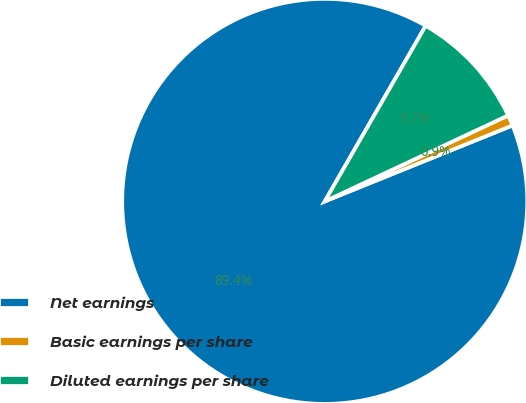Convert chart. <chart><loc_0><loc_0><loc_500><loc_500><pie_chart><fcel>Net earnings<fcel>Basic earnings per share<fcel>Diluted earnings per share<nl><fcel>89.41%<fcel>0.86%<fcel>9.72%<nl></chart> 